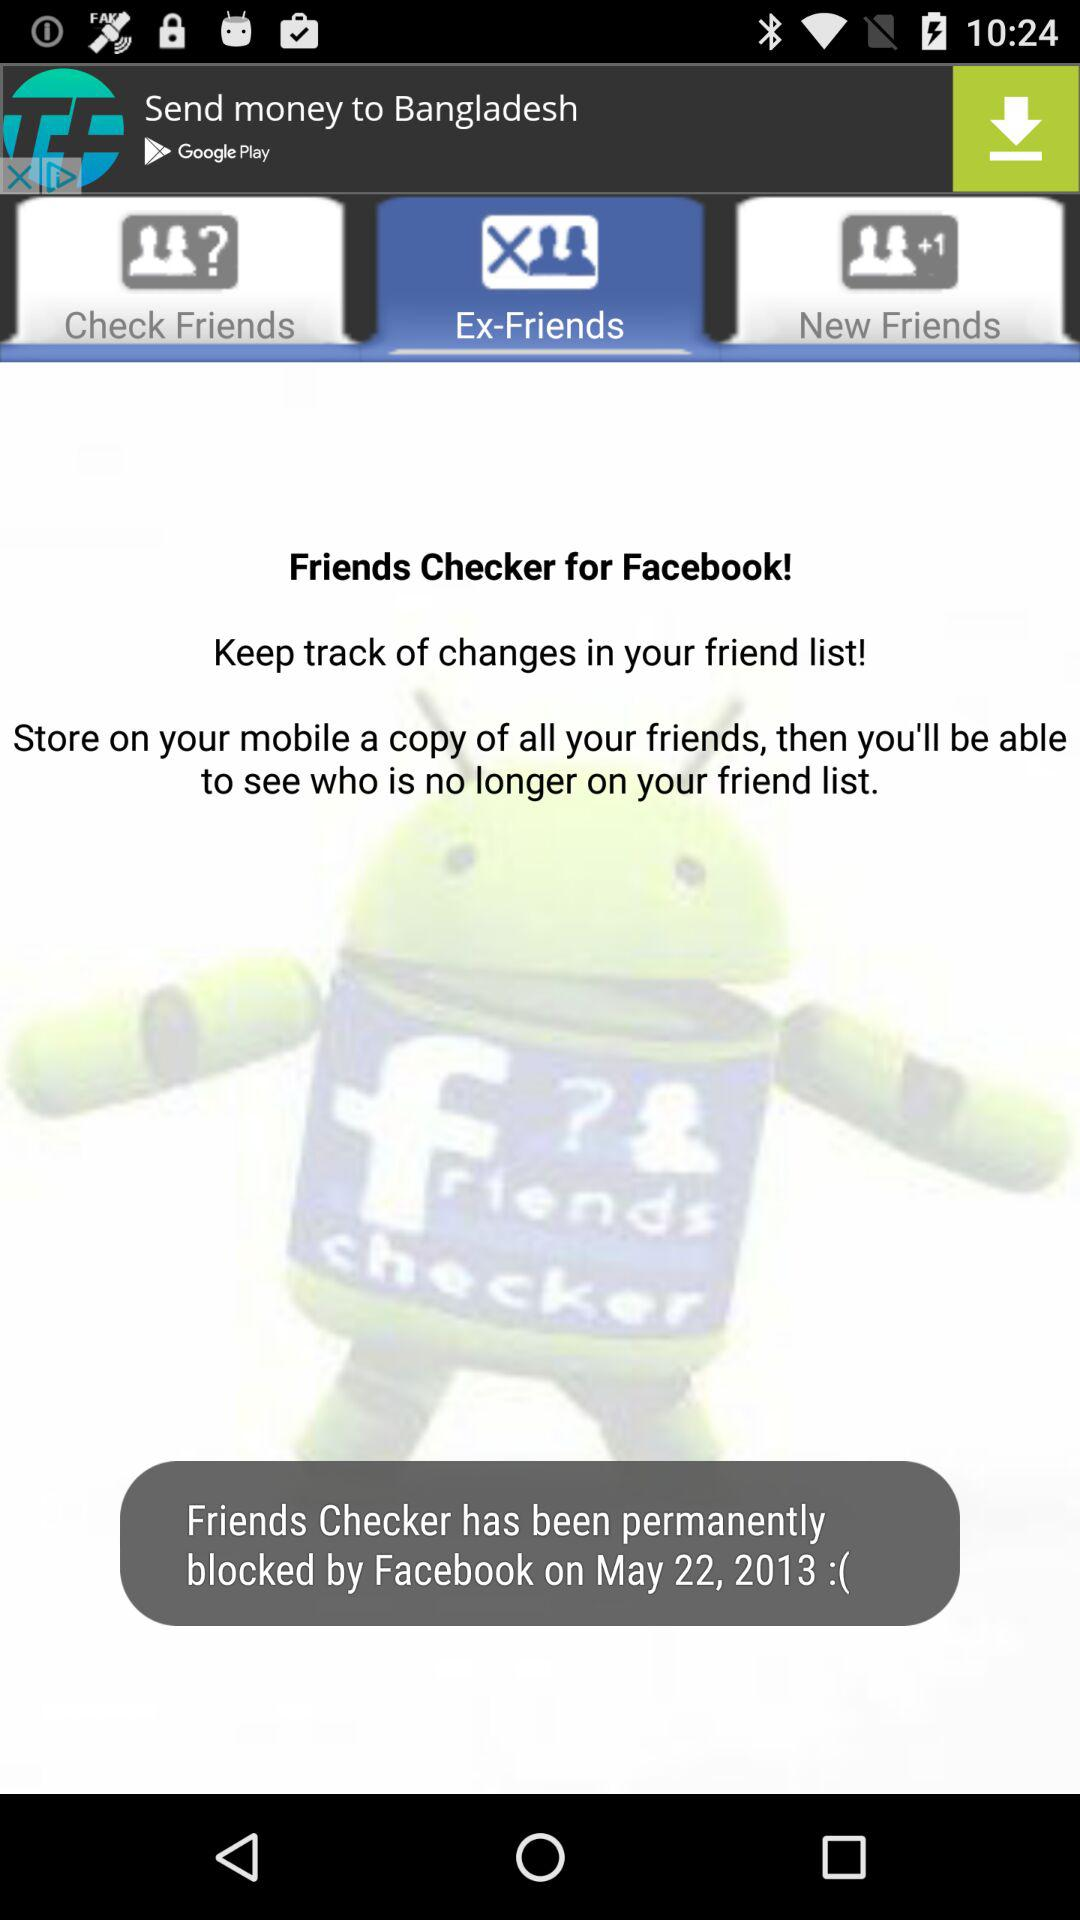Which tab is selected? The selected tab is "Ex-Friends". 